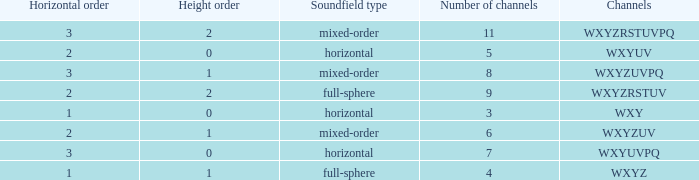If the channels is wxyzrstuvpq, what is the horizontal order? 3.0. 